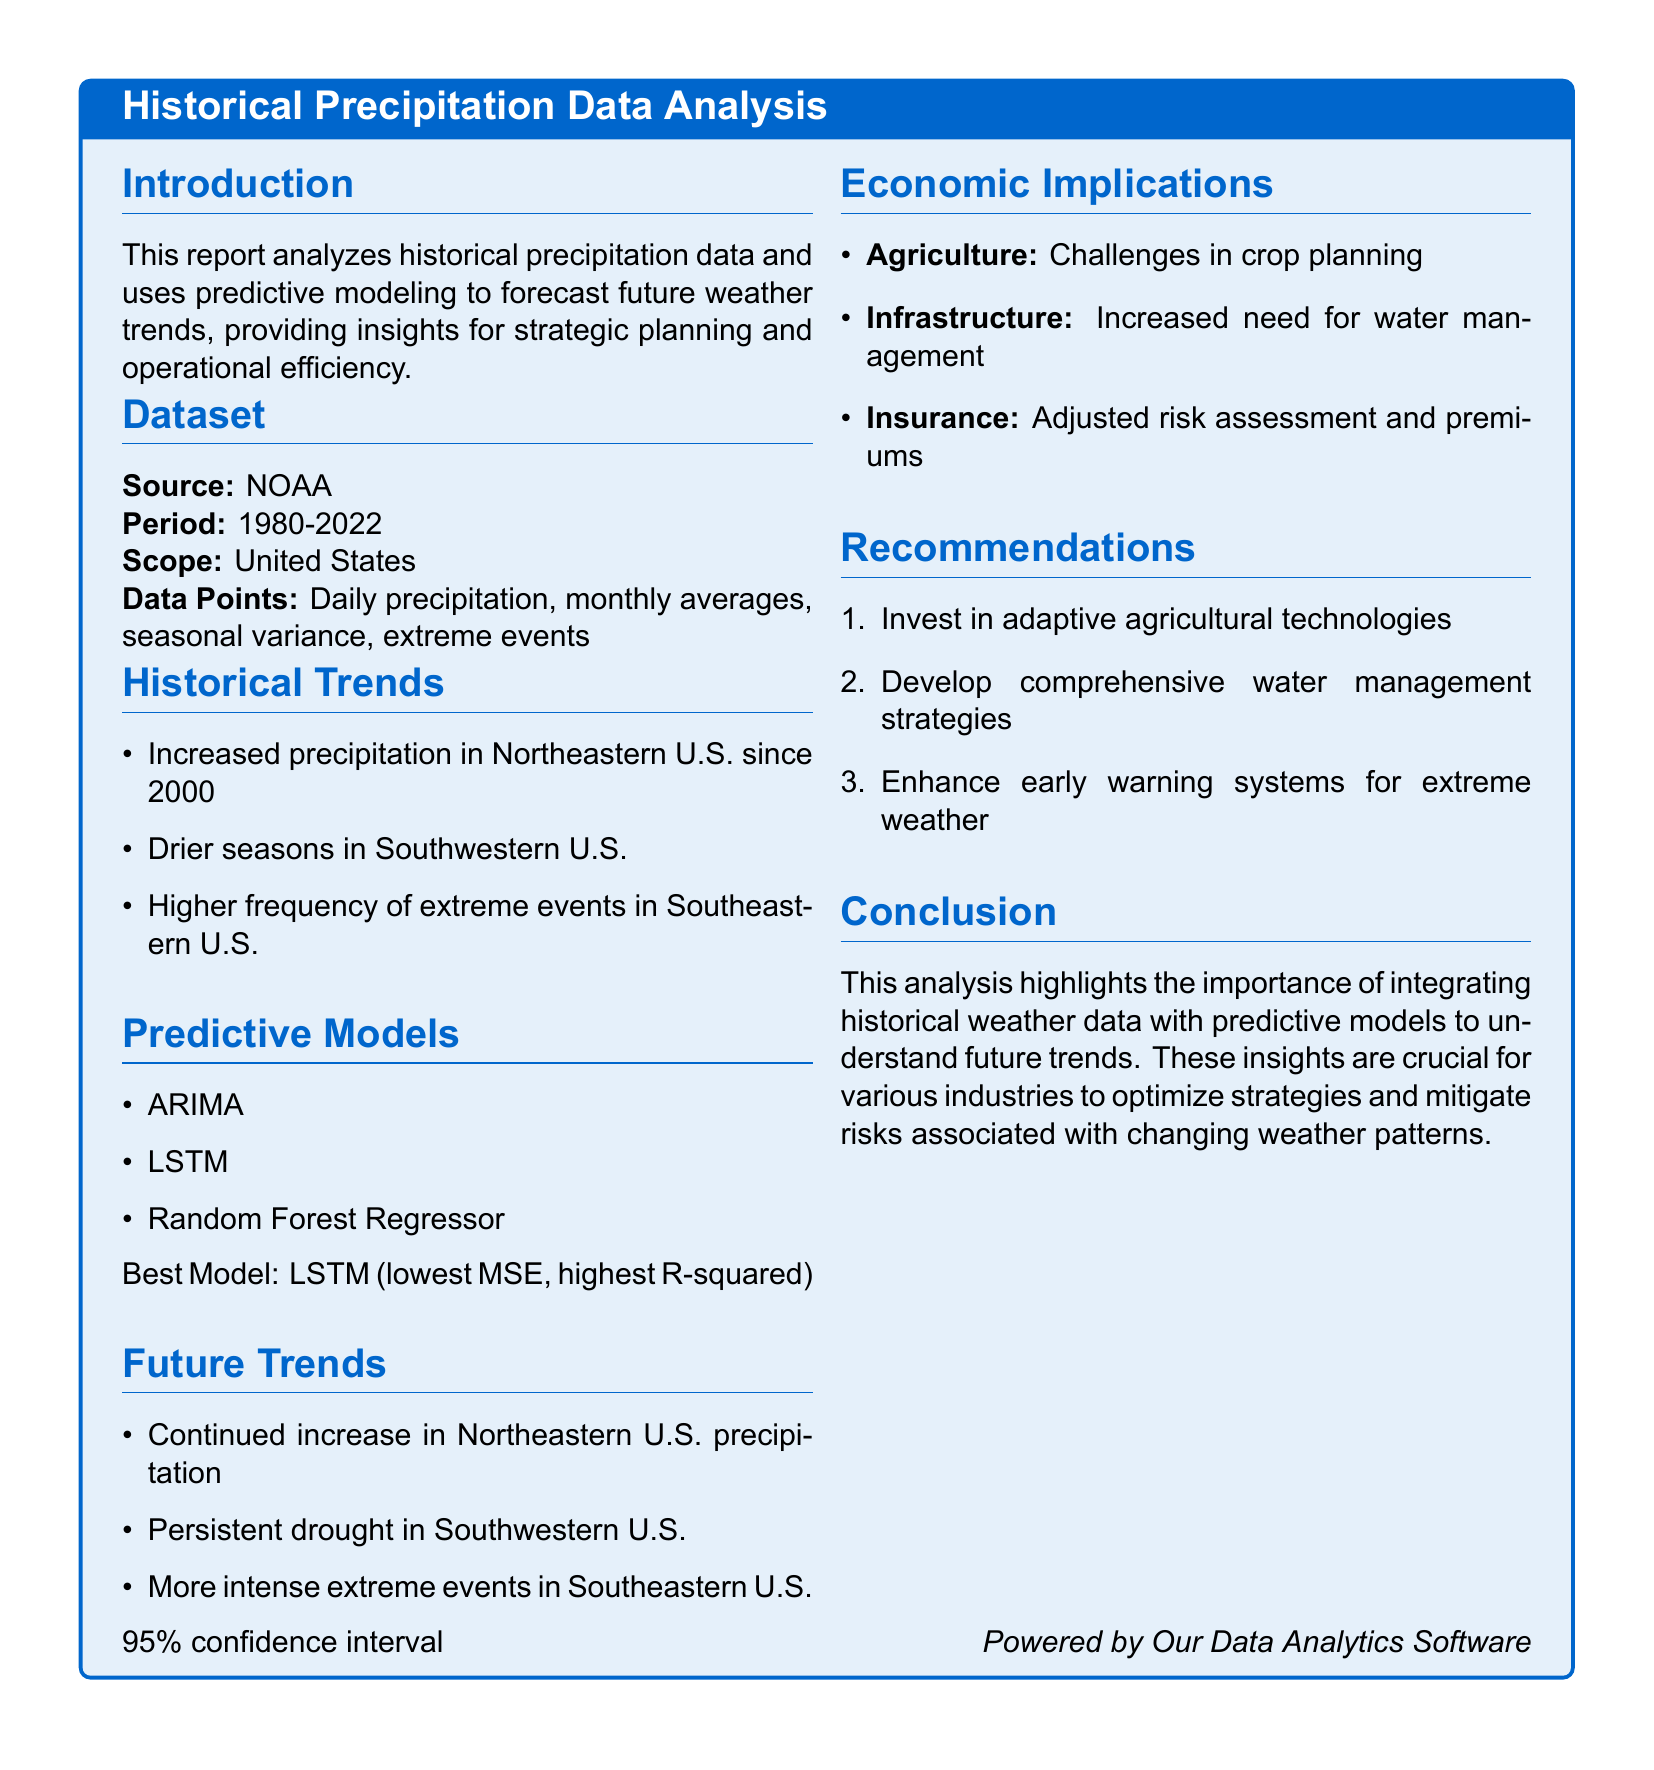What is the source of the data? The source of the data is explicitly stated in the document and refers to NOAA.
Answer: NOAA What is the period of the dataset? The dataset covers the period from 1980 to 2022, as noted in the dataset section.
Answer: 1980-2022 What is the best predictive model identified in the report? The best model is the one with the lowest MSE and highest R-squared among the listed predictive models.
Answer: LSTM What significant trend is observed in the Northeastern U.S.? This trend is outlined under the historical trends section, noting an increase in precipitation.
Answer: Increased precipitation What challenges in agriculture are mentioned in the economic implications? The document mentions specific challenges faced in agriculture regarding crop planning.
Answer: Challenges in crop planning What is the 95% statistical measure mentioned in relation to future trends? The document uses this statistical measure to indicate the degree of confidence in the predicted future trends.
Answer: Confidence interval What recommendation is provided for enhancing weather preparedness? The document offers a specific strategy aimed at improving weather preparedness against extreme events.
Answer: Enhance early warning systems What type of events has a higher frequency in the Southeastern U.S.? The historical trends section points out the nature of these weather events as having increased occurrence.
Answer: Extreme events What section discusses the implications for insurance? The economic implications section addresses how weather data influences insurance practices and assessments.
Answer: Economic Implications 